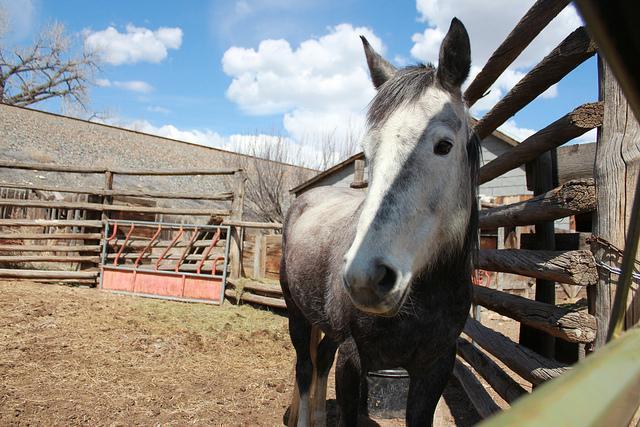How many books are on the end table?
Give a very brief answer. 0. 